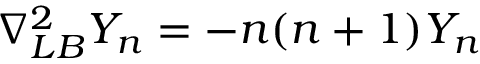<formula> <loc_0><loc_0><loc_500><loc_500>\nabla _ { L B } ^ { 2 } Y _ { n } = - n ( n + 1 ) Y _ { n }</formula> 